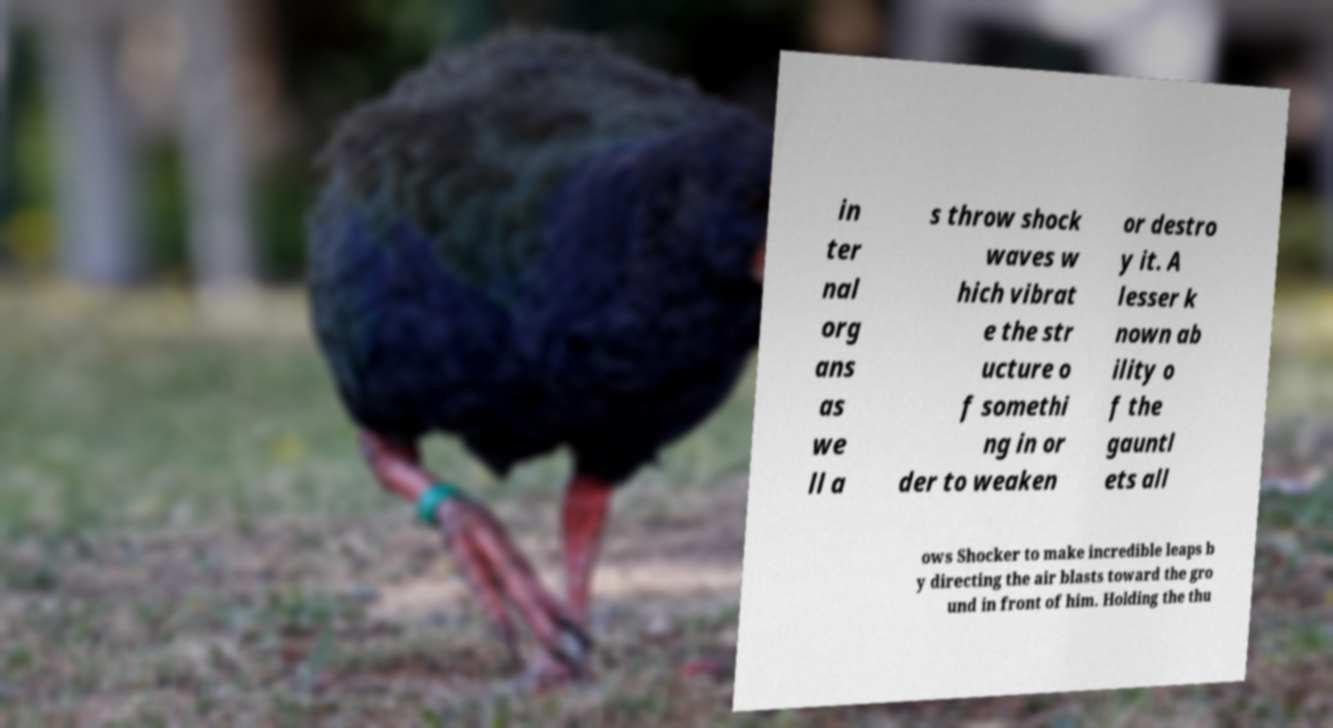Can you accurately transcribe the text from the provided image for me? in ter nal org ans as we ll a s throw shock waves w hich vibrat e the str ucture o f somethi ng in or der to weaken or destro y it. A lesser k nown ab ility o f the gauntl ets all ows Shocker to make incredible leaps b y directing the air blasts toward the gro und in front of him. Holding the thu 